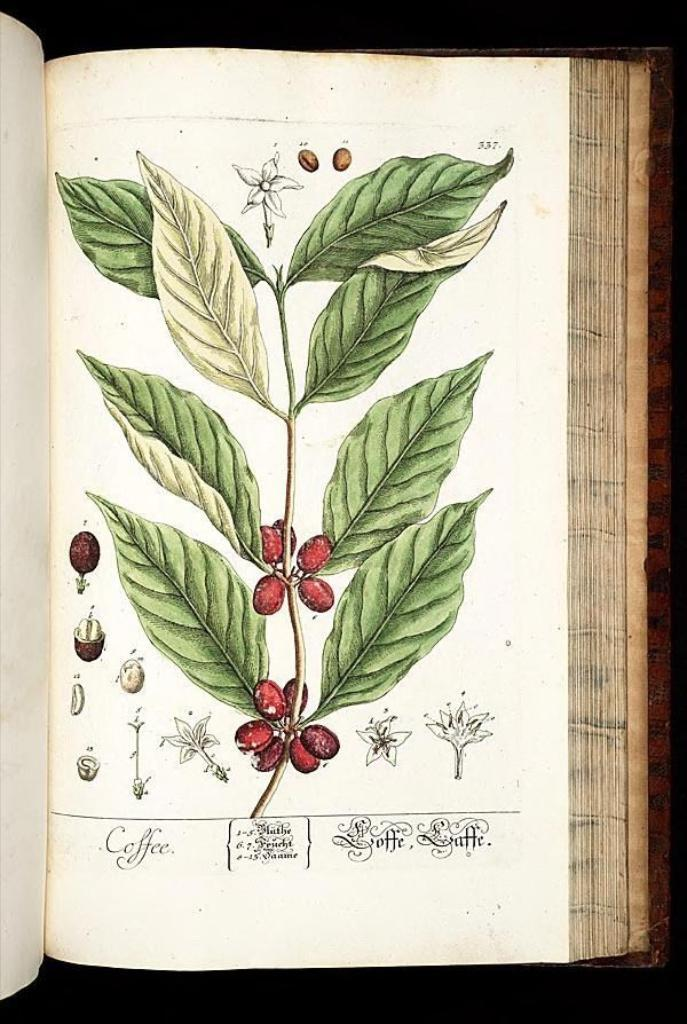What is depicted in the painting in the image? There is a painting of a book in the image. Are there any additional elements within the painting of the book? Yes, the painting of the book includes a painting of a plant. Is there any text visible on the painting? Yes, there is a name visible on the painting. What type of cheese is being used to paint the hydrant in the image? There is no hydrant or cheese present in the image; it features a painting of a book with a painting of a plant and a visible name. 